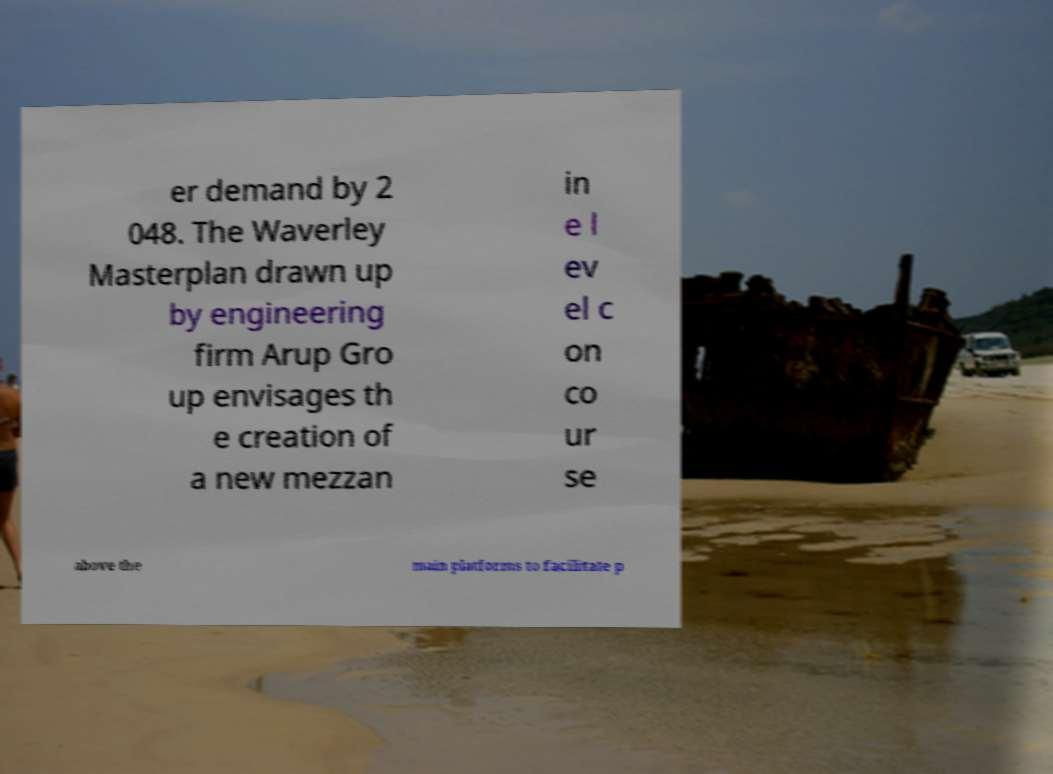Could you assist in decoding the text presented in this image and type it out clearly? er demand by 2 048. The Waverley Masterplan drawn up by engineering firm Arup Gro up envisages th e creation of a new mezzan in e l ev el c on co ur se above the main platforms to facilitate p 